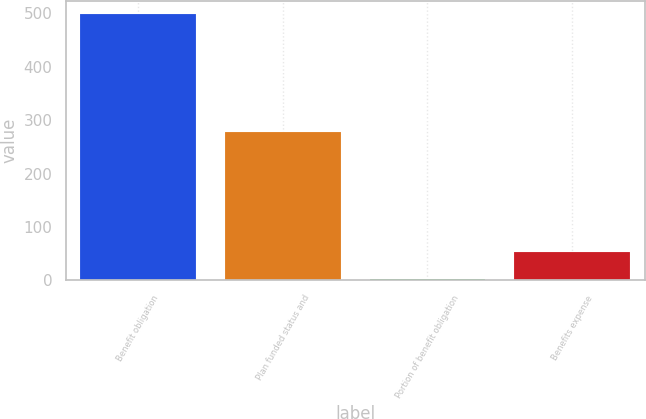<chart> <loc_0><loc_0><loc_500><loc_500><bar_chart><fcel>Benefit obligation<fcel>Plan funded status and<fcel>Portion of benefit obligation<fcel>Benefits expense<nl><fcel>498<fcel>278<fcel>3<fcel>52.5<nl></chart> 